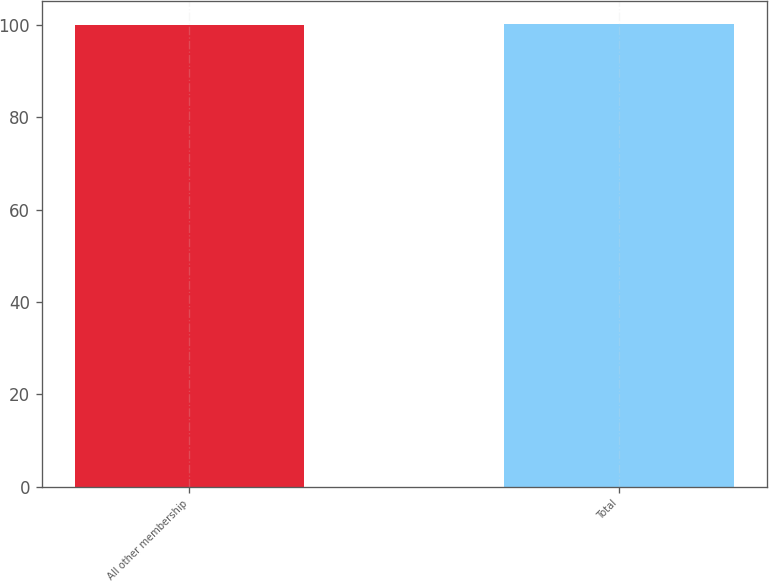<chart> <loc_0><loc_0><loc_500><loc_500><bar_chart><fcel>All other membership<fcel>Total<nl><fcel>100<fcel>100.1<nl></chart> 